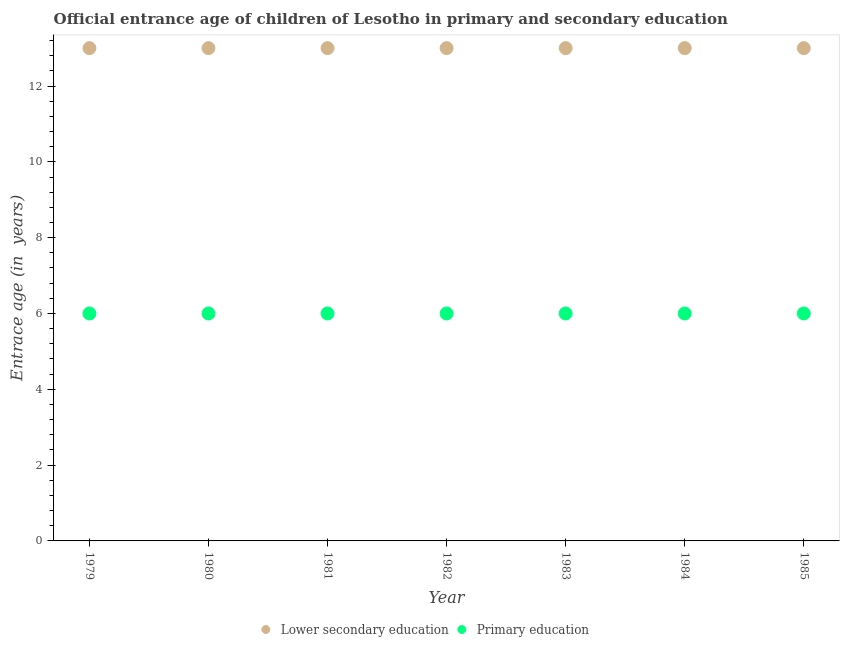How many different coloured dotlines are there?
Make the answer very short. 2. What is the entrance age of children in lower secondary education in 1983?
Your answer should be very brief. 13. Across all years, what is the minimum entrance age of chiildren in primary education?
Your response must be concise. 6. In which year was the entrance age of chiildren in primary education maximum?
Ensure brevity in your answer.  1979. In which year was the entrance age of chiildren in primary education minimum?
Ensure brevity in your answer.  1979. What is the total entrance age of children in lower secondary education in the graph?
Offer a terse response. 91. What is the difference between the entrance age of children in lower secondary education in 1979 and that in 1985?
Keep it short and to the point. 0. What is the difference between the entrance age of children in lower secondary education in 1983 and the entrance age of chiildren in primary education in 1984?
Provide a short and direct response. 7. In the year 1980, what is the difference between the entrance age of chiildren in primary education and entrance age of children in lower secondary education?
Your response must be concise. -7. Is the entrance age of children in lower secondary education in 1981 less than that in 1982?
Keep it short and to the point. No. Is the difference between the entrance age of chiildren in primary education in 1981 and 1983 greater than the difference between the entrance age of children in lower secondary education in 1981 and 1983?
Provide a short and direct response. No. What is the difference between the highest and the lowest entrance age of chiildren in primary education?
Provide a short and direct response. 0. In how many years, is the entrance age of children in lower secondary education greater than the average entrance age of children in lower secondary education taken over all years?
Ensure brevity in your answer.  0. Does the entrance age of chiildren in primary education monotonically increase over the years?
Provide a short and direct response. No. Is the entrance age of chiildren in primary education strictly greater than the entrance age of children in lower secondary education over the years?
Provide a succinct answer. No. Does the graph contain any zero values?
Your answer should be very brief. No. Does the graph contain grids?
Provide a short and direct response. No. Where does the legend appear in the graph?
Offer a terse response. Bottom center. How many legend labels are there?
Make the answer very short. 2. How are the legend labels stacked?
Give a very brief answer. Horizontal. What is the title of the graph?
Offer a very short reply. Official entrance age of children of Lesotho in primary and secondary education. Does "Measles" appear as one of the legend labels in the graph?
Your response must be concise. No. What is the label or title of the X-axis?
Your answer should be compact. Year. What is the label or title of the Y-axis?
Keep it short and to the point. Entrace age (in  years). What is the Entrace age (in  years) of Lower secondary education in 1979?
Ensure brevity in your answer.  13. What is the Entrace age (in  years) in Lower secondary education in 1980?
Give a very brief answer. 13. What is the Entrace age (in  years) of Primary education in 1980?
Offer a very short reply. 6. What is the Entrace age (in  years) in Primary education in 1981?
Keep it short and to the point. 6. What is the Entrace age (in  years) in Primary education in 1982?
Your answer should be compact. 6. What is the Entrace age (in  years) of Lower secondary education in 1984?
Offer a terse response. 13. What is the Entrace age (in  years) of Primary education in 1984?
Keep it short and to the point. 6. What is the Entrace age (in  years) in Lower secondary education in 1985?
Make the answer very short. 13. What is the Entrace age (in  years) in Primary education in 1985?
Provide a succinct answer. 6. Across all years, what is the maximum Entrace age (in  years) in Lower secondary education?
Keep it short and to the point. 13. Across all years, what is the minimum Entrace age (in  years) of Lower secondary education?
Provide a short and direct response. 13. Across all years, what is the minimum Entrace age (in  years) in Primary education?
Your answer should be compact. 6. What is the total Entrace age (in  years) of Lower secondary education in the graph?
Offer a terse response. 91. What is the total Entrace age (in  years) in Primary education in the graph?
Your answer should be compact. 42. What is the difference between the Entrace age (in  years) in Lower secondary education in 1979 and that in 1980?
Your response must be concise. 0. What is the difference between the Entrace age (in  years) of Primary education in 1979 and that in 1981?
Give a very brief answer. 0. What is the difference between the Entrace age (in  years) of Lower secondary education in 1979 and that in 1982?
Your response must be concise. 0. What is the difference between the Entrace age (in  years) in Lower secondary education in 1979 and that in 1984?
Offer a very short reply. 0. What is the difference between the Entrace age (in  years) of Lower secondary education in 1979 and that in 1985?
Your answer should be compact. 0. What is the difference between the Entrace age (in  years) of Lower secondary education in 1980 and that in 1981?
Your answer should be very brief. 0. What is the difference between the Entrace age (in  years) in Primary education in 1980 and that in 1981?
Your answer should be very brief. 0. What is the difference between the Entrace age (in  years) in Primary education in 1980 and that in 1982?
Your answer should be very brief. 0. What is the difference between the Entrace age (in  years) of Lower secondary education in 1980 and that in 1984?
Offer a terse response. 0. What is the difference between the Entrace age (in  years) in Primary education in 1980 and that in 1984?
Offer a terse response. 0. What is the difference between the Entrace age (in  years) of Lower secondary education in 1981 and that in 1982?
Ensure brevity in your answer.  0. What is the difference between the Entrace age (in  years) in Primary education in 1981 and that in 1982?
Keep it short and to the point. 0. What is the difference between the Entrace age (in  years) in Primary education in 1981 and that in 1985?
Provide a succinct answer. 0. What is the difference between the Entrace age (in  years) in Lower secondary education in 1982 and that in 1983?
Provide a succinct answer. 0. What is the difference between the Entrace age (in  years) of Lower secondary education in 1982 and that in 1984?
Give a very brief answer. 0. What is the difference between the Entrace age (in  years) of Lower secondary education in 1982 and that in 1985?
Your answer should be compact. 0. What is the difference between the Entrace age (in  years) of Primary education in 1982 and that in 1985?
Make the answer very short. 0. What is the difference between the Entrace age (in  years) in Lower secondary education in 1983 and that in 1985?
Provide a succinct answer. 0. What is the difference between the Entrace age (in  years) in Lower secondary education in 1979 and the Entrace age (in  years) in Primary education in 1982?
Offer a terse response. 7. What is the difference between the Entrace age (in  years) of Lower secondary education in 1979 and the Entrace age (in  years) of Primary education in 1983?
Your answer should be compact. 7. What is the difference between the Entrace age (in  years) in Lower secondary education in 1979 and the Entrace age (in  years) in Primary education in 1984?
Your answer should be very brief. 7. What is the difference between the Entrace age (in  years) in Lower secondary education in 1980 and the Entrace age (in  years) in Primary education in 1983?
Your response must be concise. 7. What is the difference between the Entrace age (in  years) in Lower secondary education in 1980 and the Entrace age (in  years) in Primary education in 1984?
Make the answer very short. 7. What is the difference between the Entrace age (in  years) of Lower secondary education in 1980 and the Entrace age (in  years) of Primary education in 1985?
Your answer should be very brief. 7. What is the difference between the Entrace age (in  years) in Lower secondary education in 1981 and the Entrace age (in  years) in Primary education in 1982?
Provide a short and direct response. 7. What is the difference between the Entrace age (in  years) in Lower secondary education in 1982 and the Entrace age (in  years) in Primary education in 1983?
Offer a terse response. 7. In the year 1979, what is the difference between the Entrace age (in  years) in Lower secondary education and Entrace age (in  years) in Primary education?
Your response must be concise. 7. In the year 1981, what is the difference between the Entrace age (in  years) of Lower secondary education and Entrace age (in  years) of Primary education?
Make the answer very short. 7. In the year 1982, what is the difference between the Entrace age (in  years) of Lower secondary education and Entrace age (in  years) of Primary education?
Keep it short and to the point. 7. In the year 1983, what is the difference between the Entrace age (in  years) of Lower secondary education and Entrace age (in  years) of Primary education?
Make the answer very short. 7. What is the ratio of the Entrace age (in  years) of Lower secondary education in 1979 to that in 1981?
Provide a succinct answer. 1. What is the ratio of the Entrace age (in  years) of Primary education in 1979 to that in 1981?
Provide a succinct answer. 1. What is the ratio of the Entrace age (in  years) in Lower secondary education in 1979 to that in 1983?
Ensure brevity in your answer.  1. What is the ratio of the Entrace age (in  years) in Primary education in 1979 to that in 1983?
Provide a succinct answer. 1. What is the ratio of the Entrace age (in  years) in Lower secondary education in 1979 to that in 1984?
Offer a very short reply. 1. What is the ratio of the Entrace age (in  years) of Lower secondary education in 1979 to that in 1985?
Offer a very short reply. 1. What is the ratio of the Entrace age (in  years) of Primary education in 1979 to that in 1985?
Keep it short and to the point. 1. What is the ratio of the Entrace age (in  years) of Primary education in 1980 to that in 1982?
Your answer should be compact. 1. What is the ratio of the Entrace age (in  years) in Lower secondary education in 1980 to that in 1983?
Provide a short and direct response. 1. What is the ratio of the Entrace age (in  years) of Primary education in 1980 to that in 1983?
Your answer should be very brief. 1. What is the ratio of the Entrace age (in  years) in Primary education in 1980 to that in 1984?
Your answer should be compact. 1. What is the ratio of the Entrace age (in  years) of Lower secondary education in 1980 to that in 1985?
Make the answer very short. 1. What is the ratio of the Entrace age (in  years) in Primary education in 1980 to that in 1985?
Your answer should be compact. 1. What is the ratio of the Entrace age (in  years) of Lower secondary education in 1981 to that in 1982?
Make the answer very short. 1. What is the ratio of the Entrace age (in  years) in Primary education in 1981 to that in 1984?
Your answer should be very brief. 1. What is the ratio of the Entrace age (in  years) of Lower secondary education in 1981 to that in 1985?
Offer a terse response. 1. What is the ratio of the Entrace age (in  years) of Primary education in 1981 to that in 1985?
Ensure brevity in your answer.  1. What is the ratio of the Entrace age (in  years) of Lower secondary education in 1982 to that in 1984?
Your answer should be very brief. 1. What is the ratio of the Entrace age (in  years) in Lower secondary education in 1983 to that in 1984?
Make the answer very short. 1. What is the ratio of the Entrace age (in  years) of Primary education in 1983 to that in 1984?
Offer a very short reply. 1. What is the ratio of the Entrace age (in  years) in Lower secondary education in 1983 to that in 1985?
Make the answer very short. 1. What is the ratio of the Entrace age (in  years) of Primary education in 1984 to that in 1985?
Provide a short and direct response. 1. What is the difference between the highest and the second highest Entrace age (in  years) of Lower secondary education?
Provide a succinct answer. 0. What is the difference between the highest and the second highest Entrace age (in  years) of Primary education?
Your answer should be compact. 0. 